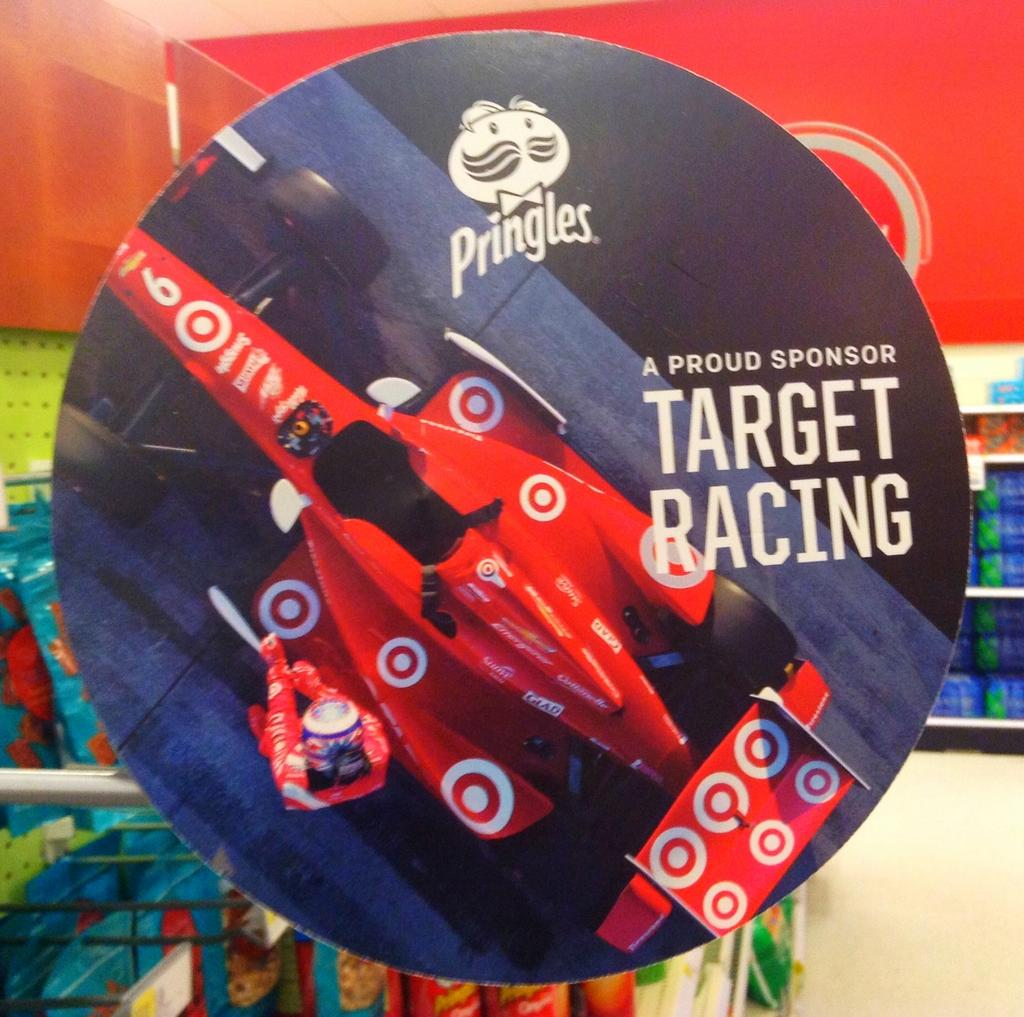What is the main object in the image? There is a board in the image. What can be seen in the background of the image? There are racks in the background of the image. What type of whip is being used to clean the board in the image? There is no whip present in the image, and the board is not being cleaned. 